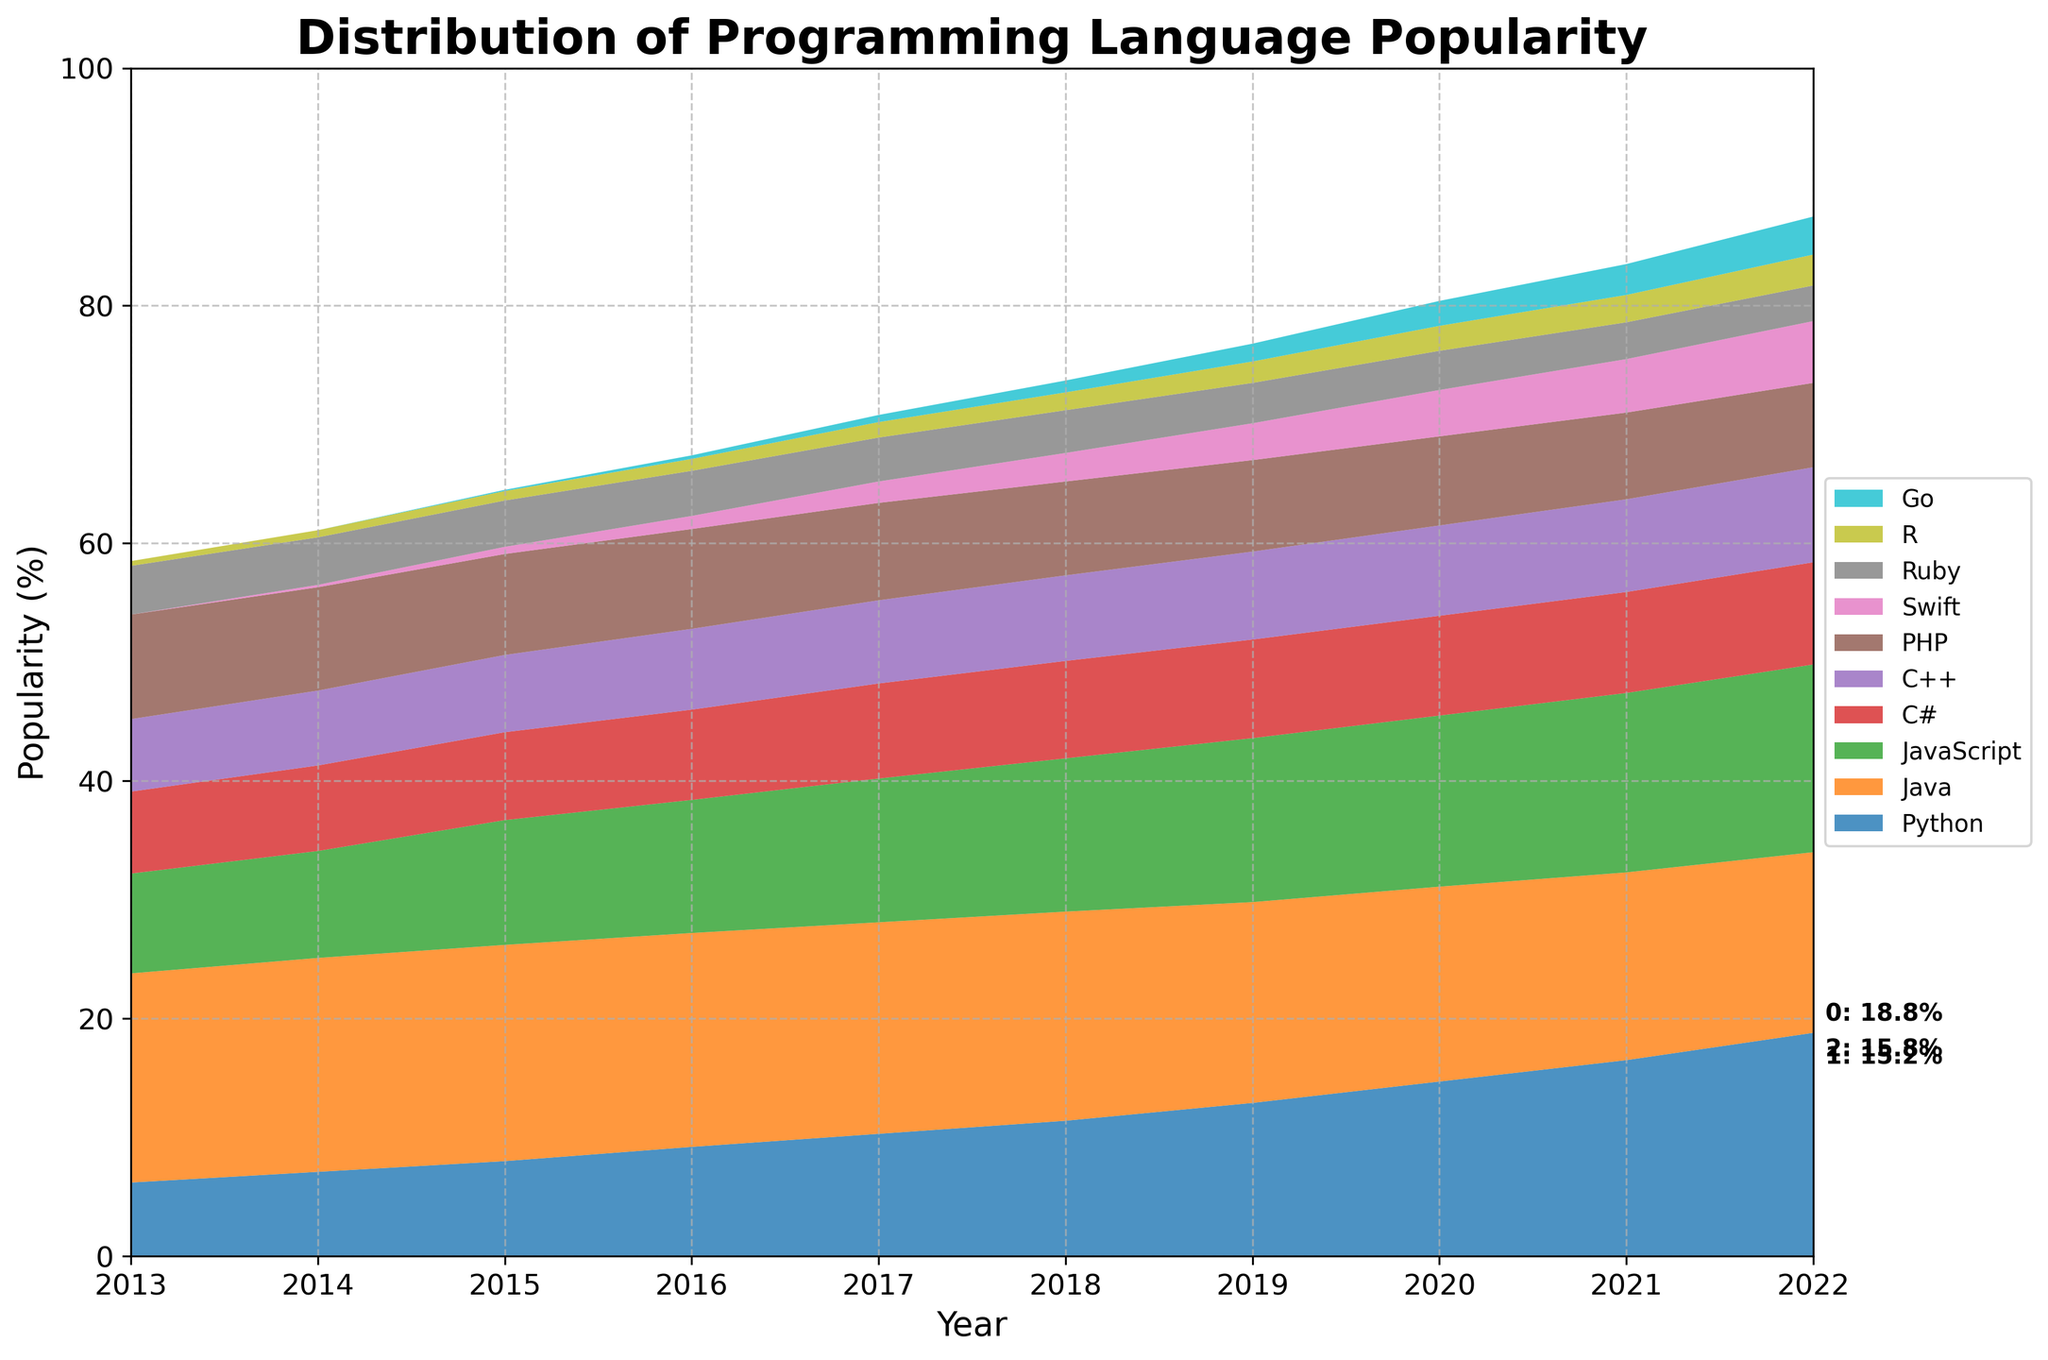What is the title of the figure? The title of the figure is located at the top and typically summarizes the main context of the graph. In this case, it reads "Distribution of Programming Language Popularity."
Answer: Distribution of Programming Language Popularity Which programming language increased in popularity the most from 2013 to 2022? To identify the language with the largest increase, we examine the starting and ending points for each language and find the one with the greatest difference in percentage. Python rose from 6.2% in 2013 to 18.8% in 2022.
Answer: Python Compare the popularity of Java and Python in 2022. Which one is more popular? To compare, look at the values for both Java and Python in 2022. Python is at 18.8% while Java is at 15.2%.
Answer: Python How did the popularity of PHP change over the years? Observe the trend line for PHP from 2013 to 2022. It starts at 8.8% in 2013 and gradually decreases to 7.1% in 2022.
Answer: It decreased What are the top 3 programming languages in 2022? The top 3 are annotated on the graph for 2022. Python, Java, and JavaScript are the most popular.
Answer: Python, Java, JavaScript Which year did Go start appearing in the popularity chart? By looking at the data series for Go, it becomes visible on the chart starting at the year when its percentage is first logged, which is 2015.
Answer: 2015 What is the trend of Swift's popularity from 2014 to 2022? Review the line for Swift between 2014 and 2022. Swift starts at 0.2% in 2014 and consistently rises to 5.2% by 2022.
Answer: Increasing Which programming language had the smallest increase in popularity from 2013 to 2022? Calculate the difference in percentages from 2013 to 2022 for all languages and find the smallest increase. Ruby changed from 4.1% to 3.0%, indicating the smallest and actually negative growth.
Answer: Ruby During which year did Python surpass JavaScript in popularity? Compare the trend lines of Python and JavaScript year by year. Python surpasses JavaScript in 2020.
Answer: 2020 What was the combined popularity of C# and C++ in the year 2017? Sum the percentages for C# and C++ in 2017. C# was 8.0% and C++ was 7.0%, making a total of 15.0%.
Answer: 15.0% 